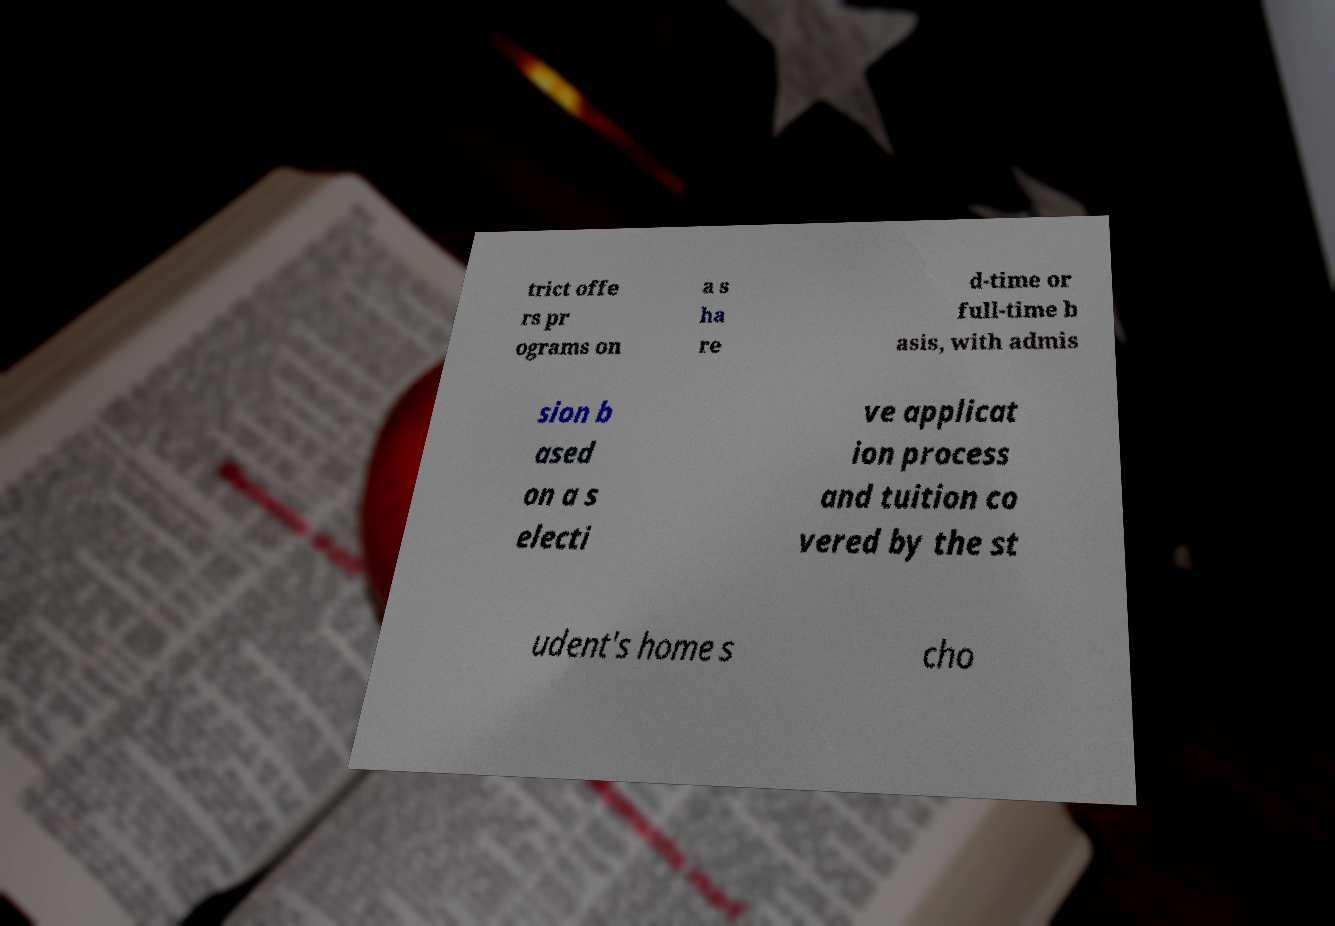For documentation purposes, I need the text within this image transcribed. Could you provide that? trict offe rs pr ograms on a s ha re d-time or full-time b asis, with admis sion b ased on a s electi ve applicat ion process and tuition co vered by the st udent's home s cho 